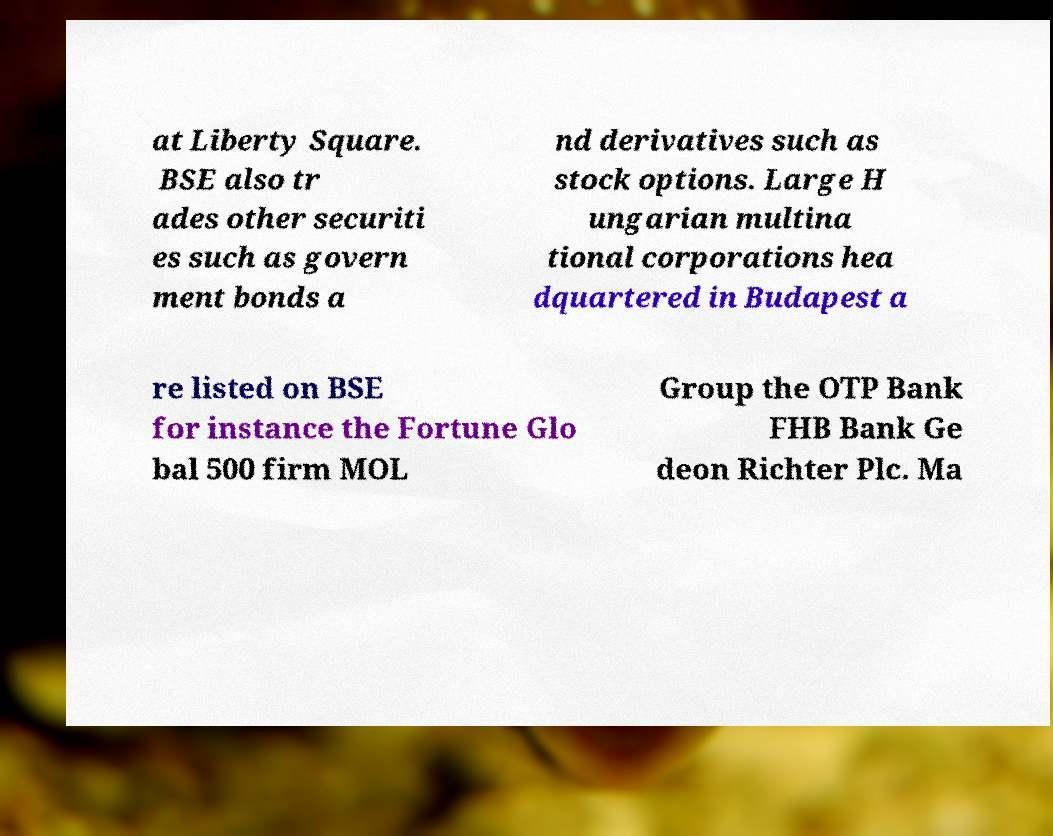Could you assist in decoding the text presented in this image and type it out clearly? at Liberty Square. BSE also tr ades other securiti es such as govern ment bonds a nd derivatives such as stock options. Large H ungarian multina tional corporations hea dquartered in Budapest a re listed on BSE for instance the Fortune Glo bal 500 firm MOL Group the OTP Bank FHB Bank Ge deon Richter Plc. Ma 